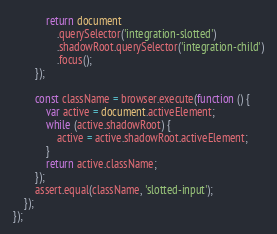Convert code to text. <code><loc_0><loc_0><loc_500><loc_500><_JavaScript_>            return document
                .querySelector('integration-slotted')
                .shadowRoot.querySelector('integration-child')
                .focus();
        });

        const className = browser.execute(function () {
            var active = document.activeElement;
            while (active.shadowRoot) {
                active = active.shadowRoot.activeElement;
            }
            return active.className;
        });
        assert.equal(className, 'slotted-input');
    });
});
</code> 